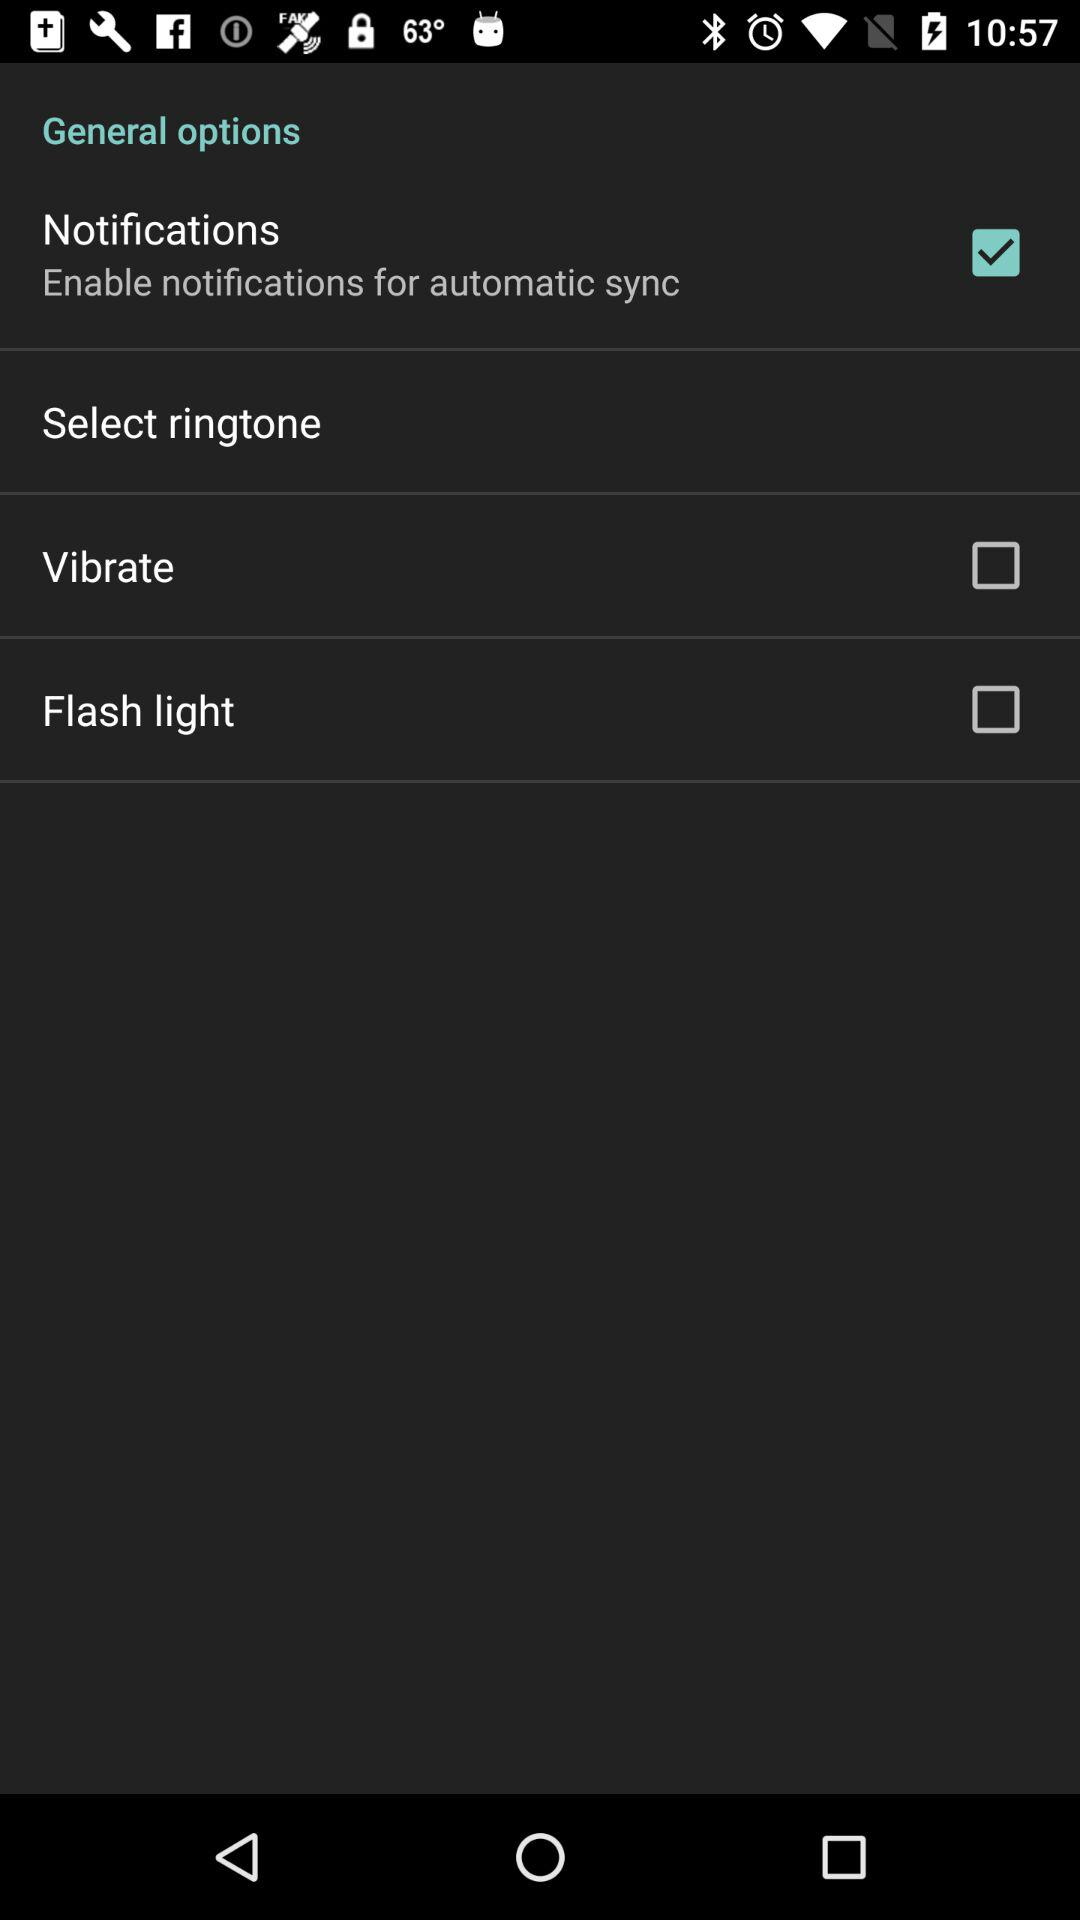What is the status of "Notifications"? The status of "Notifications" is "on". 